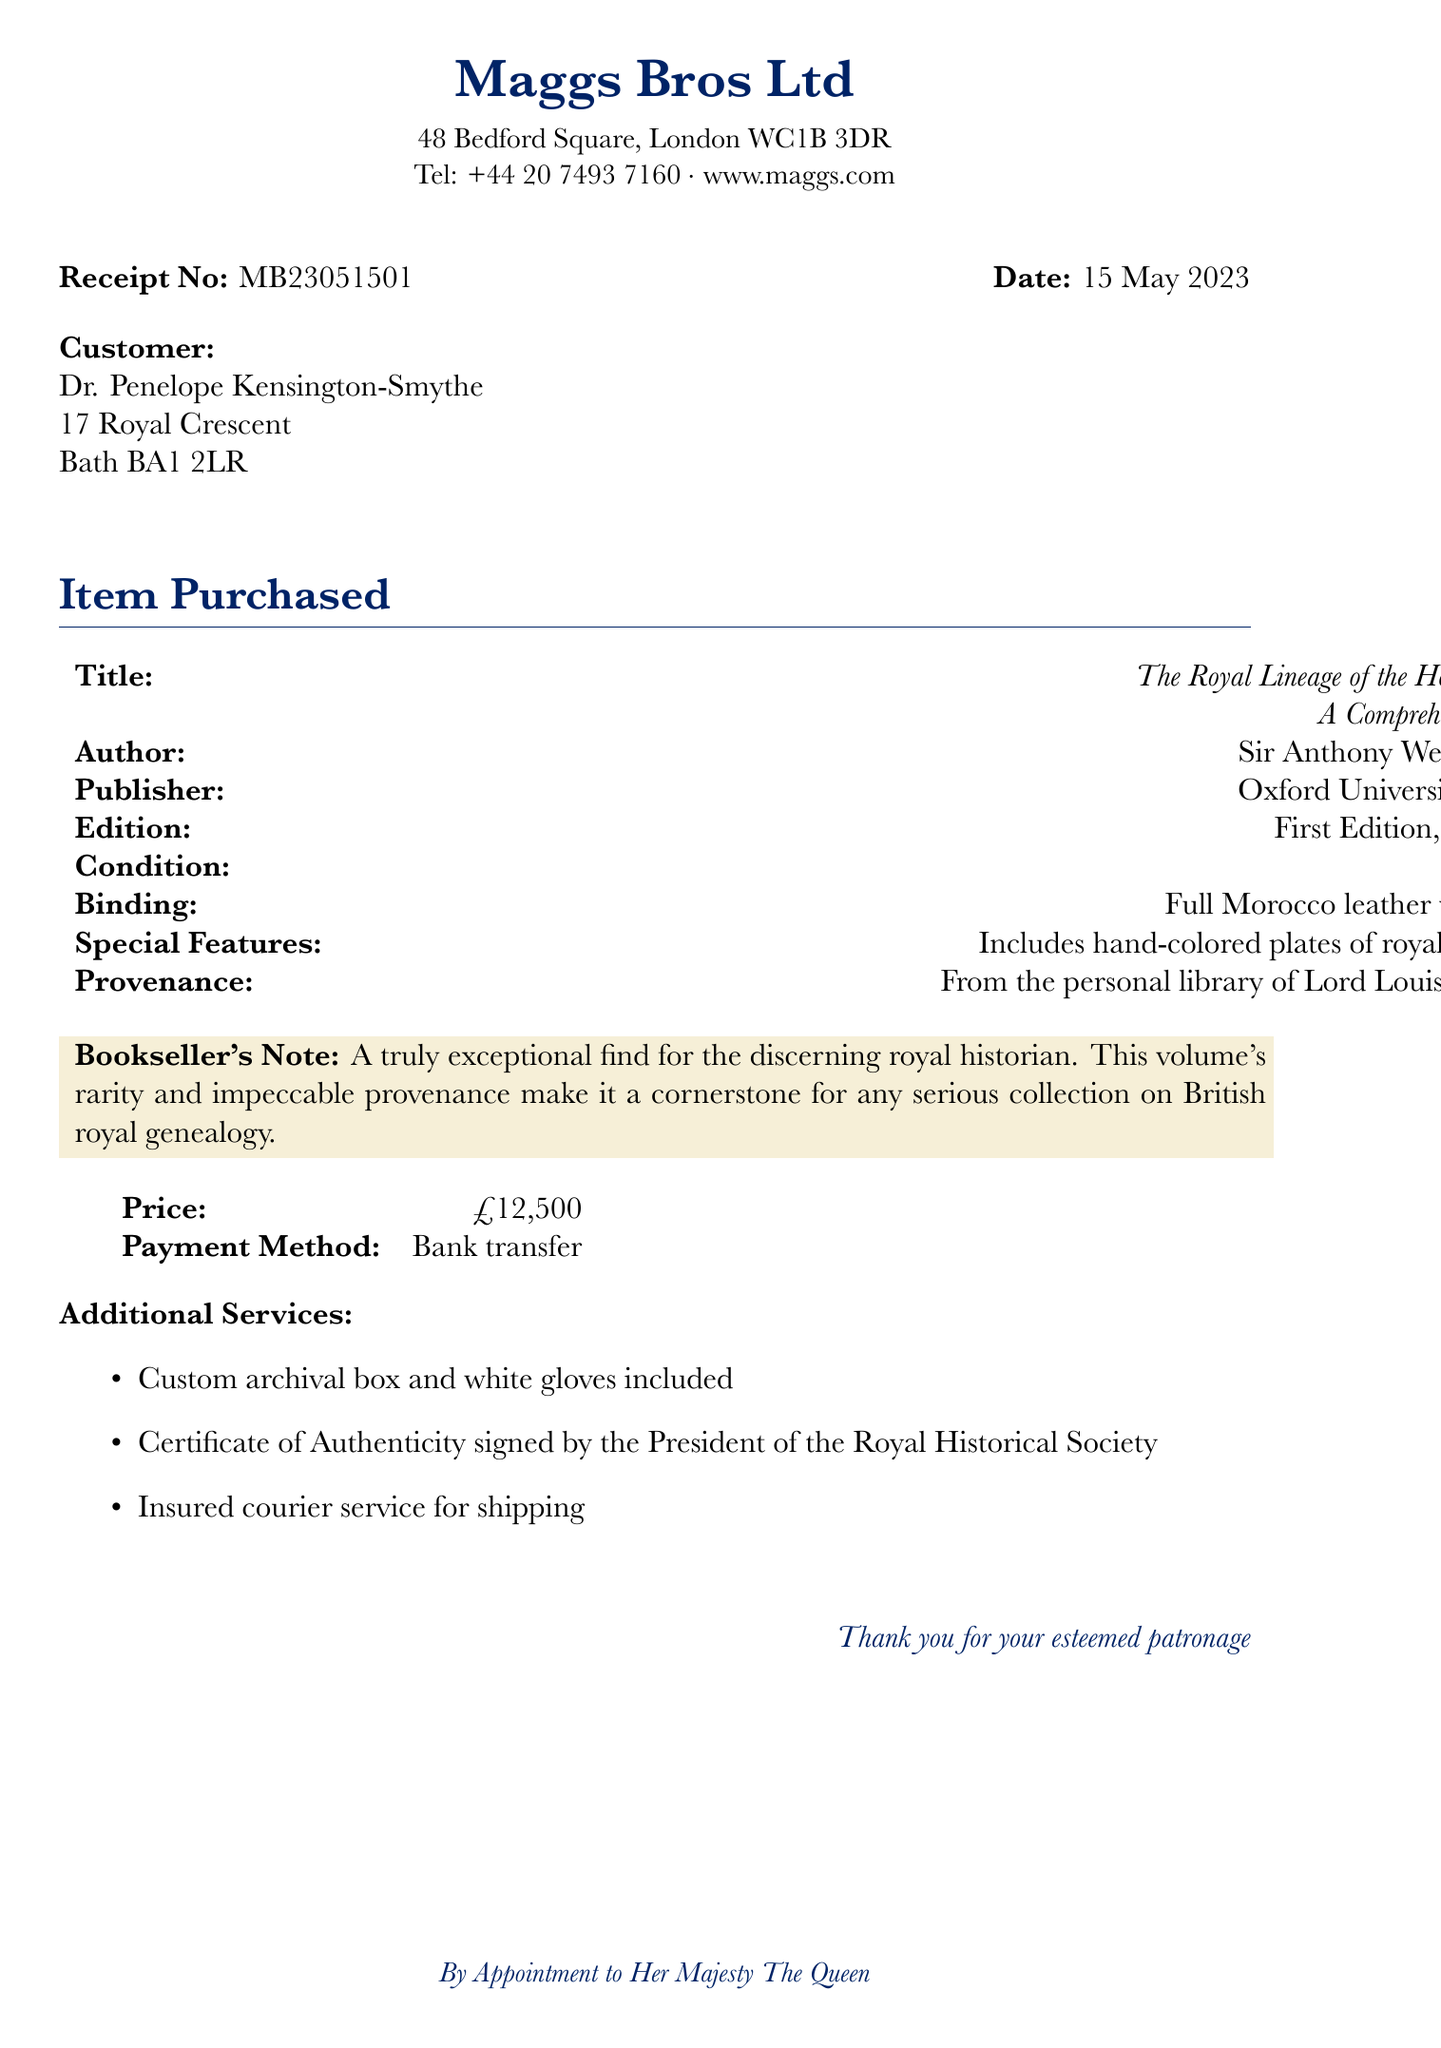What is the name of the bookshop? The bookshop's name is provided prominently at the top of the document.
Answer: Maggs Bros Ltd What is the address of the bookshop? The address of the bookshop is listed just below the name in the document.
Answer: 48 Bedford Square, London WC1B 3DR Who is the author of the book? The author is specified in the section that describes the item purchased.
Answer: Sir Anthony Wedgwood-Benn What was the price of the book? The price is mentioned clearly in the summary of the item purchased.
Answer: £12,500 What is the special feature of the book? The special features are listed in the details about the book purchased.
Answer: Includes hand-colored plates of royal coats of arms What payment method was used? The payment method is explicitly stated in the financial details of the receipt.
Answer: Bank transfer What is the provenance of the book? The provenance is a significant detail highlighted in the description of the item.
Answer: From the personal library of Lord Louis Mountbatten What additional services were included with the purchase? The receipt outlines the extra services provided in a dedicated section.
Answer: Custom archival box and white gloves included What is the publication year of the book? The publication year is part of the book details listed in the document.
Answer: 1953 What does the bookseller's note say? The note provides an appraisal of the book's significance for collectors and historians.
Answer: A truly exceptional find for the discerning royal historian. This volume's rarity and impeccable provenance make it a cornerstone for any serious collection on British royal genealogy 